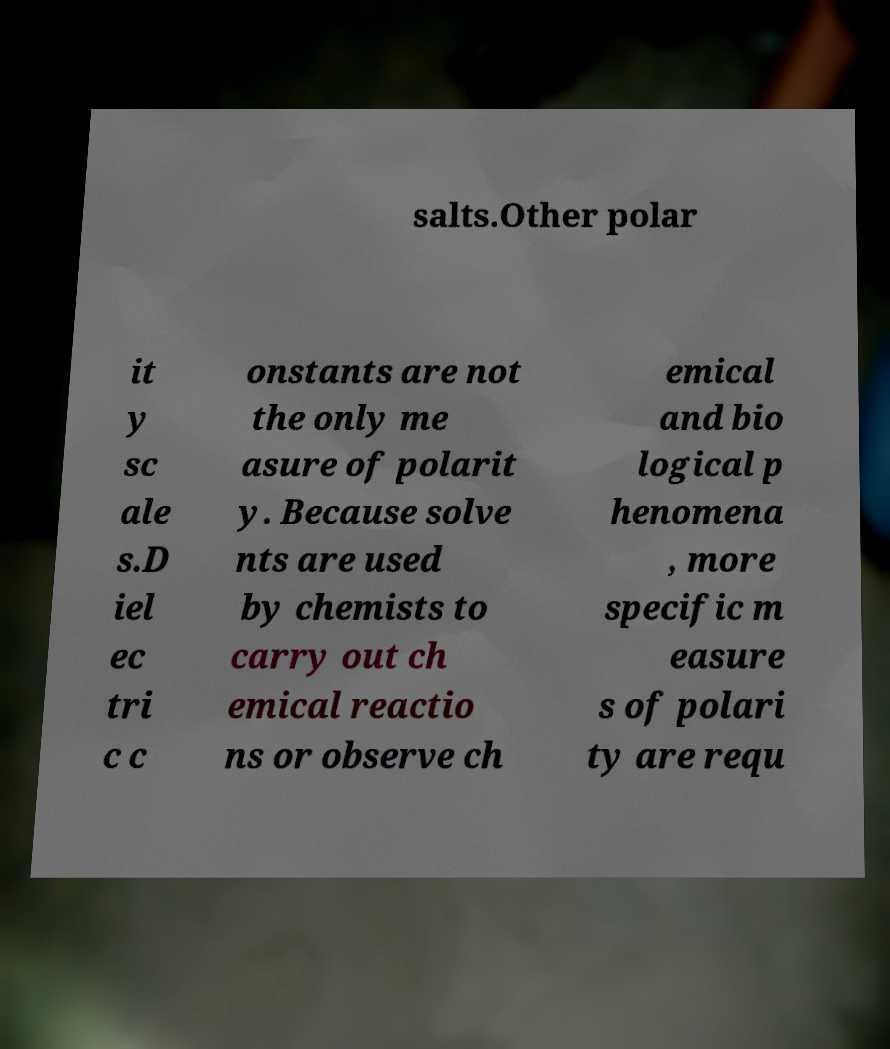Could you extract and type out the text from this image? salts.Other polar it y sc ale s.D iel ec tri c c onstants are not the only me asure of polarit y. Because solve nts are used by chemists to carry out ch emical reactio ns or observe ch emical and bio logical p henomena , more specific m easure s of polari ty are requ 